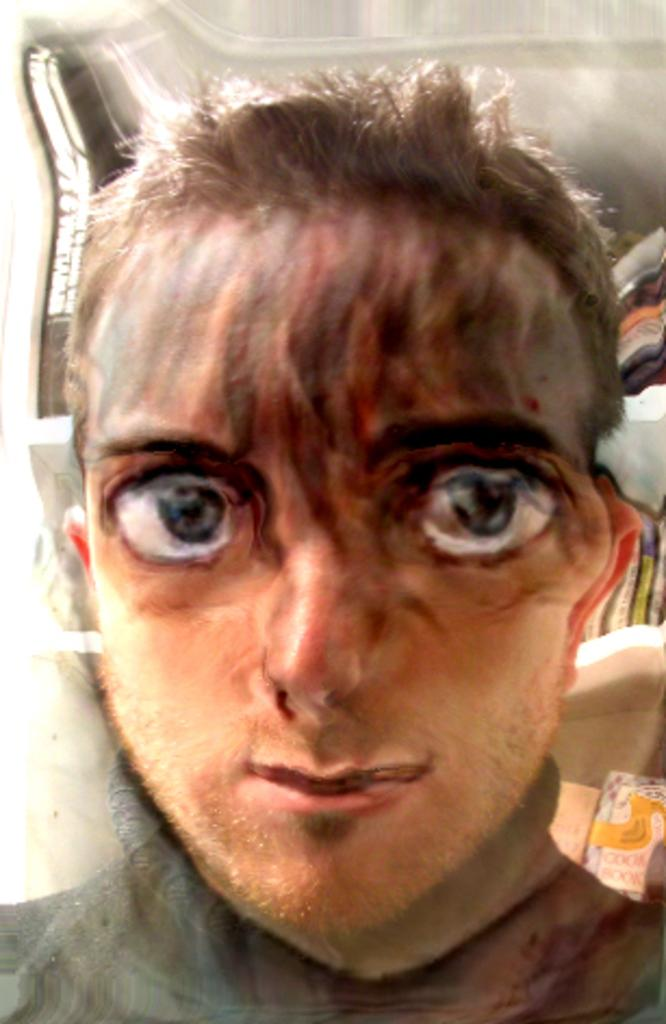What is the main subject of the image? The main subject of the image is an edited image of a person. What can be seen behind the person in the image? There are books placed on shelves on the backside of the person. What type of sun can be seen in the image? There is no sun present in the image; it is an edited image of a person with books placed on shelves behind them. 